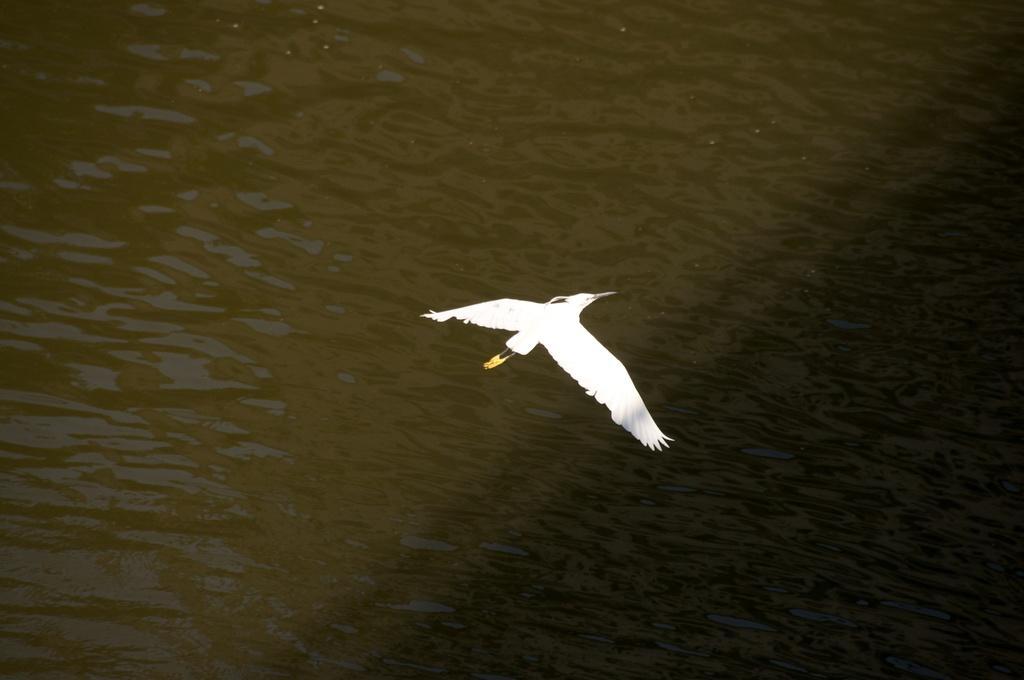Please provide a concise description of this image. In the image we can see a bird, white in color and the bird is flying. This is a water. 